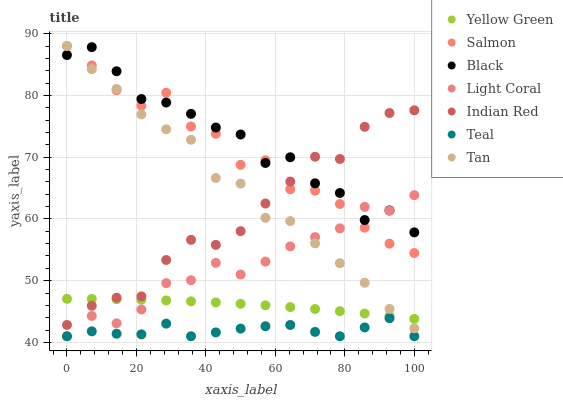Does Teal have the minimum area under the curve?
Answer yes or no. Yes. Does Black have the maximum area under the curve?
Answer yes or no. Yes. Does Salmon have the minimum area under the curve?
Answer yes or no. No. Does Salmon have the maximum area under the curve?
Answer yes or no. No. Is Yellow Green the smoothest?
Answer yes or no. Yes. Is Salmon the roughest?
Answer yes or no. Yes. Is Light Coral the smoothest?
Answer yes or no. No. Is Light Coral the roughest?
Answer yes or no. No. Does Light Coral have the lowest value?
Answer yes or no. Yes. Does Salmon have the lowest value?
Answer yes or no. No. Does Tan have the highest value?
Answer yes or no. Yes. Does Light Coral have the highest value?
Answer yes or no. No. Is Teal less than Tan?
Answer yes or no. Yes. Is Yellow Green greater than Teal?
Answer yes or no. Yes. Does Teal intersect Light Coral?
Answer yes or no. Yes. Is Teal less than Light Coral?
Answer yes or no. No. Is Teal greater than Light Coral?
Answer yes or no. No. Does Teal intersect Tan?
Answer yes or no. No. 